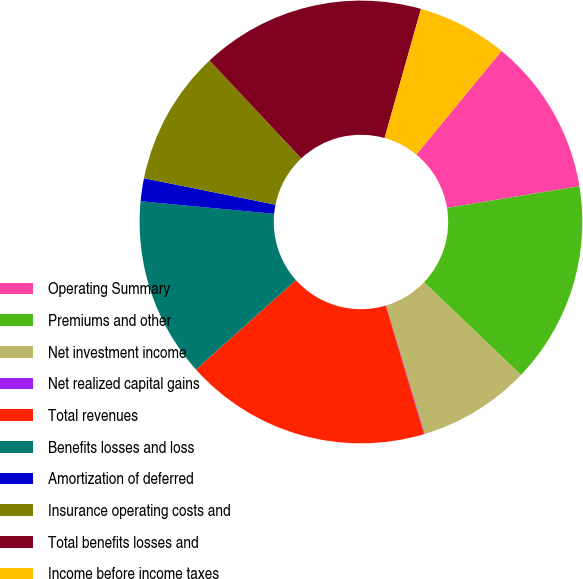Convert chart. <chart><loc_0><loc_0><loc_500><loc_500><pie_chart><fcel>Operating Summary<fcel>Premiums and other<fcel>Net investment income<fcel>Net realized capital gains<fcel>Total revenues<fcel>Benefits losses and loss<fcel>Amortization of deferred<fcel>Insurance operating costs and<fcel>Total benefits losses and<fcel>Income before income taxes<nl><fcel>11.47%<fcel>14.73%<fcel>8.21%<fcel>0.05%<fcel>17.99%<fcel>13.1%<fcel>1.68%<fcel>9.84%<fcel>16.36%<fcel>6.58%<nl></chart> 